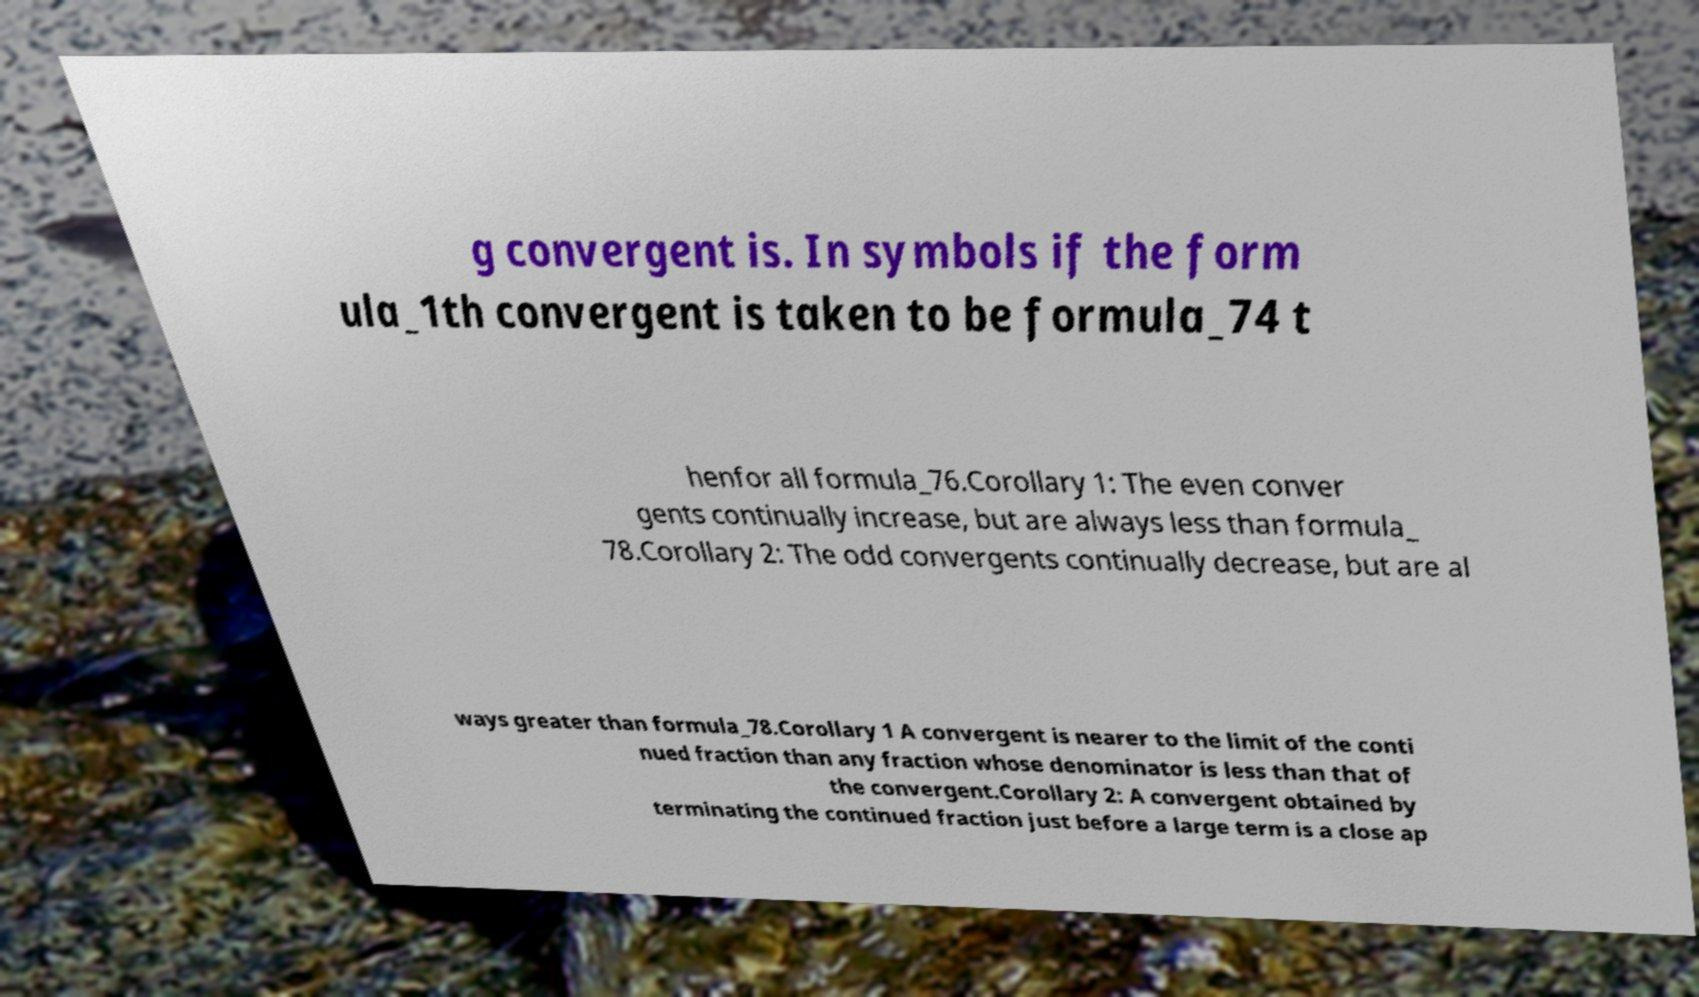For documentation purposes, I need the text within this image transcribed. Could you provide that? g convergent is. In symbols if the form ula_1th convergent is taken to be formula_74 t henfor all formula_76.Corollary 1: The even conver gents continually increase, but are always less than formula_ 78.Corollary 2: The odd convergents continually decrease, but are al ways greater than formula_78.Corollary 1 A convergent is nearer to the limit of the conti nued fraction than any fraction whose denominator is less than that of the convergent.Corollary 2: A convergent obtained by terminating the continued fraction just before a large term is a close ap 